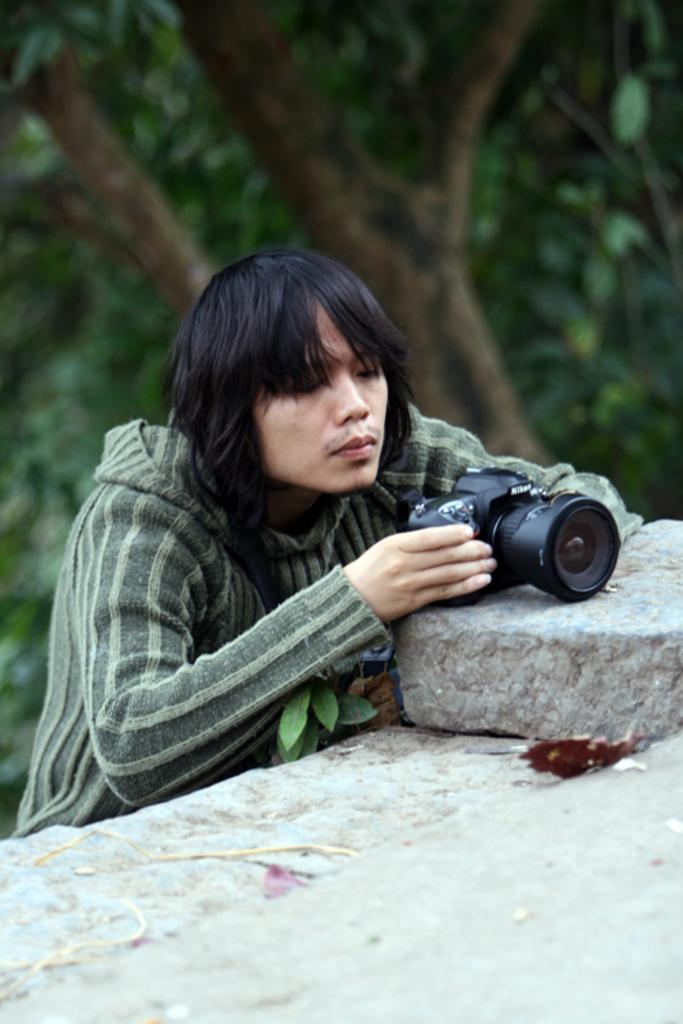Who is present in the image? There is a man in the image. What is the man holding in his hand? The man is holding a camera with his hand. What is the object the man is holding? The object the man is holding is a camera. What can be seen in the background of the image? There is a tree in the background of the image. What other object is present in the image? There is a stone in the image. What type of leaf is the man holding in his hand? The man is not holding a leaf in his hand; he is holding a camera. 